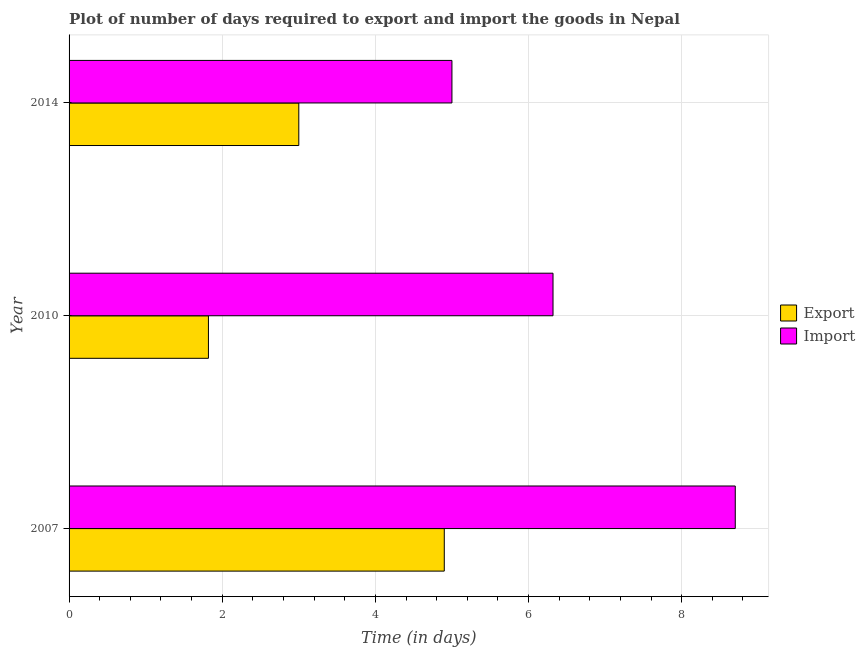How many groups of bars are there?
Keep it short and to the point. 3. Are the number of bars on each tick of the Y-axis equal?
Keep it short and to the point. Yes. How many bars are there on the 2nd tick from the bottom?
Your answer should be compact. 2. What is the label of the 2nd group of bars from the top?
Offer a very short reply. 2010. In how many cases, is the number of bars for a given year not equal to the number of legend labels?
Offer a very short reply. 0. What is the time required to export in 2014?
Offer a terse response. 3. Across all years, what is the minimum time required to import?
Make the answer very short. 5. In which year was the time required to import maximum?
Offer a very short reply. 2007. In which year was the time required to export minimum?
Offer a terse response. 2010. What is the total time required to import in the graph?
Your answer should be very brief. 20.02. What is the difference between the time required to import in 2007 and that in 2014?
Your answer should be compact. 3.7. What is the difference between the time required to export in 2010 and the time required to import in 2014?
Your response must be concise. -3.18. What is the average time required to import per year?
Give a very brief answer. 6.67. In the year 2014, what is the difference between the time required to import and time required to export?
Your answer should be very brief. 2. What is the ratio of the time required to import in 2007 to that in 2010?
Keep it short and to the point. 1.38. Is the time required to export in 2010 less than that in 2014?
Offer a very short reply. Yes. What is the difference between the highest and the second highest time required to export?
Your answer should be compact. 1.9. What is the difference between the highest and the lowest time required to export?
Provide a short and direct response. 3.08. In how many years, is the time required to import greater than the average time required to import taken over all years?
Your answer should be compact. 1. What does the 1st bar from the top in 2014 represents?
Give a very brief answer. Import. What does the 1st bar from the bottom in 2014 represents?
Ensure brevity in your answer.  Export. How many years are there in the graph?
Make the answer very short. 3. What is the difference between two consecutive major ticks on the X-axis?
Your response must be concise. 2. Does the graph contain any zero values?
Your answer should be compact. No. Does the graph contain grids?
Make the answer very short. Yes. Where does the legend appear in the graph?
Your response must be concise. Center right. How many legend labels are there?
Give a very brief answer. 2. What is the title of the graph?
Keep it short and to the point. Plot of number of days required to export and import the goods in Nepal. What is the label or title of the X-axis?
Provide a short and direct response. Time (in days). What is the Time (in days) in Export in 2010?
Ensure brevity in your answer.  1.82. What is the Time (in days) of Import in 2010?
Provide a short and direct response. 6.32. What is the Time (in days) in Export in 2014?
Your answer should be very brief. 3. Across all years, what is the minimum Time (in days) of Export?
Give a very brief answer. 1.82. Across all years, what is the minimum Time (in days) of Import?
Offer a terse response. 5. What is the total Time (in days) of Export in the graph?
Give a very brief answer. 9.72. What is the total Time (in days) in Import in the graph?
Give a very brief answer. 20.02. What is the difference between the Time (in days) in Export in 2007 and that in 2010?
Ensure brevity in your answer.  3.08. What is the difference between the Time (in days) in Import in 2007 and that in 2010?
Your answer should be compact. 2.38. What is the difference between the Time (in days) in Import in 2007 and that in 2014?
Ensure brevity in your answer.  3.7. What is the difference between the Time (in days) in Export in 2010 and that in 2014?
Your answer should be compact. -1.18. What is the difference between the Time (in days) in Import in 2010 and that in 2014?
Provide a short and direct response. 1.32. What is the difference between the Time (in days) in Export in 2007 and the Time (in days) in Import in 2010?
Your response must be concise. -1.42. What is the difference between the Time (in days) in Export in 2010 and the Time (in days) in Import in 2014?
Your answer should be very brief. -3.18. What is the average Time (in days) in Export per year?
Keep it short and to the point. 3.24. What is the average Time (in days) in Import per year?
Offer a very short reply. 6.67. In the year 2010, what is the difference between the Time (in days) of Export and Time (in days) of Import?
Offer a terse response. -4.5. What is the ratio of the Time (in days) in Export in 2007 to that in 2010?
Ensure brevity in your answer.  2.69. What is the ratio of the Time (in days) of Import in 2007 to that in 2010?
Your response must be concise. 1.38. What is the ratio of the Time (in days) in Export in 2007 to that in 2014?
Make the answer very short. 1.63. What is the ratio of the Time (in days) of Import in 2007 to that in 2014?
Your response must be concise. 1.74. What is the ratio of the Time (in days) in Export in 2010 to that in 2014?
Offer a very short reply. 0.61. What is the ratio of the Time (in days) in Import in 2010 to that in 2014?
Your response must be concise. 1.26. What is the difference between the highest and the second highest Time (in days) in Export?
Your answer should be compact. 1.9. What is the difference between the highest and the second highest Time (in days) of Import?
Provide a succinct answer. 2.38. What is the difference between the highest and the lowest Time (in days) of Export?
Provide a succinct answer. 3.08. What is the difference between the highest and the lowest Time (in days) in Import?
Offer a terse response. 3.7. 